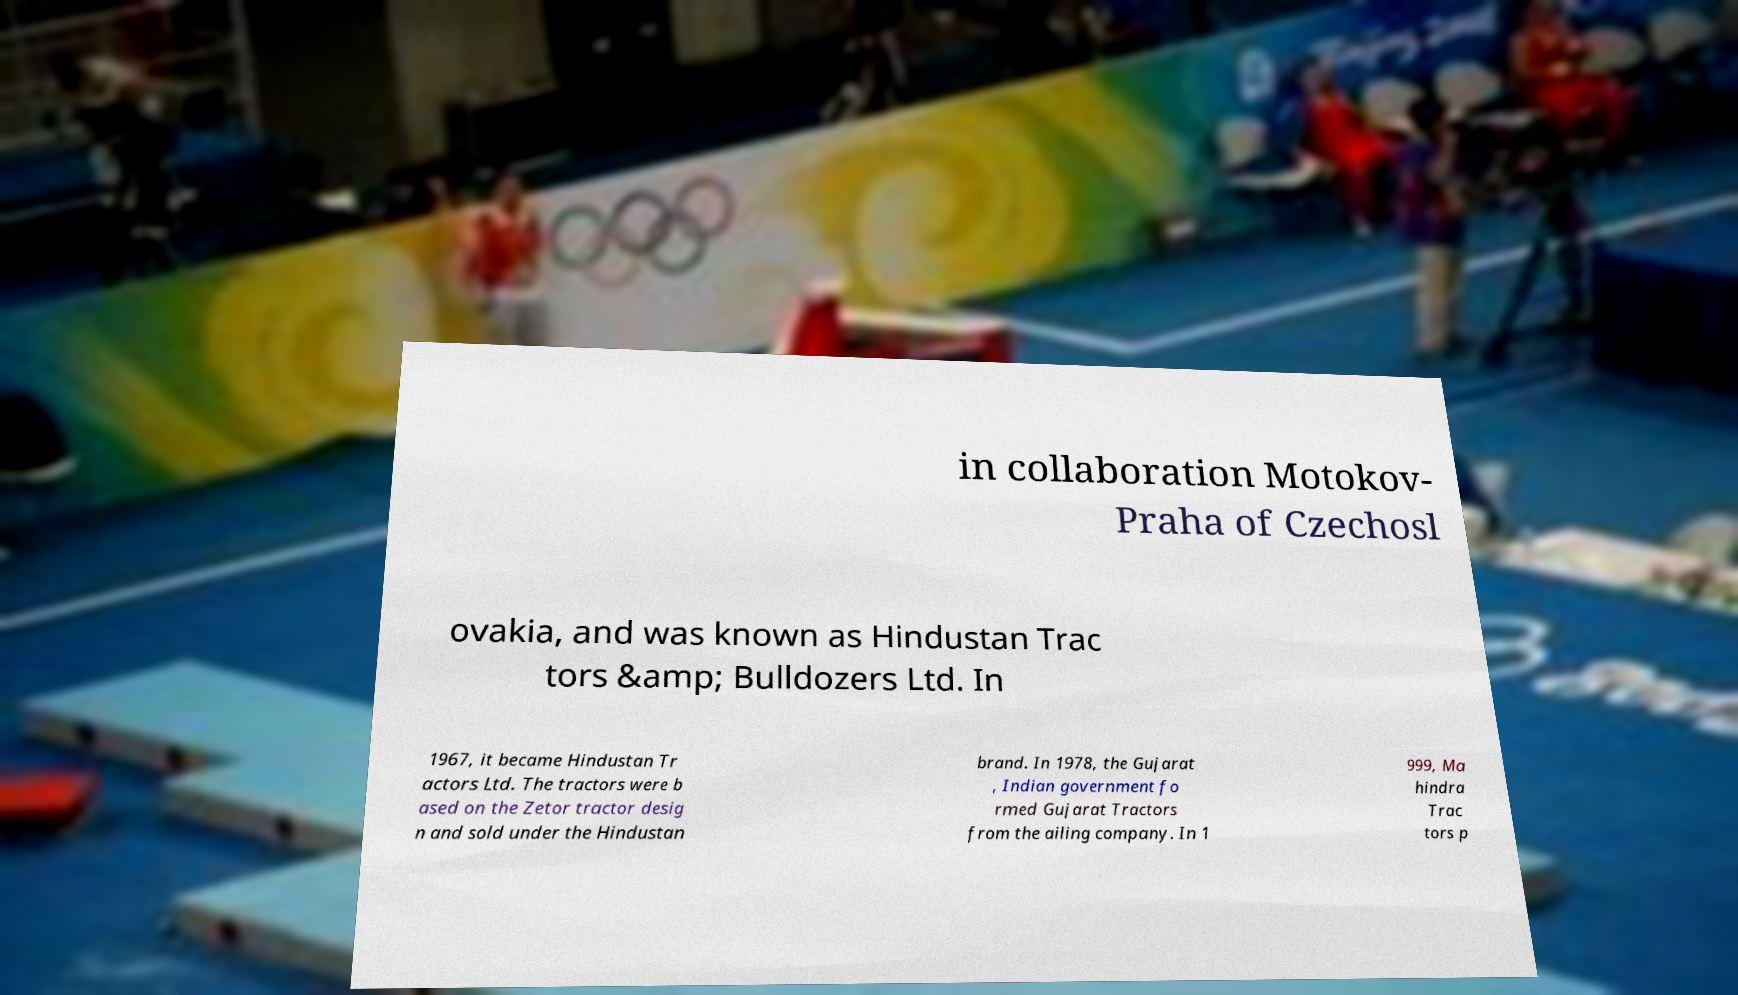Can you accurately transcribe the text from the provided image for me? in collaboration Motokov- Praha of Czechosl ovakia, and was known as Hindustan Trac tors &amp; Bulldozers Ltd. In 1967, it became Hindustan Tr actors Ltd. The tractors were b ased on the Zetor tractor desig n and sold under the Hindustan brand. In 1978, the Gujarat , Indian government fo rmed Gujarat Tractors from the ailing company. In 1 999, Ma hindra Trac tors p 